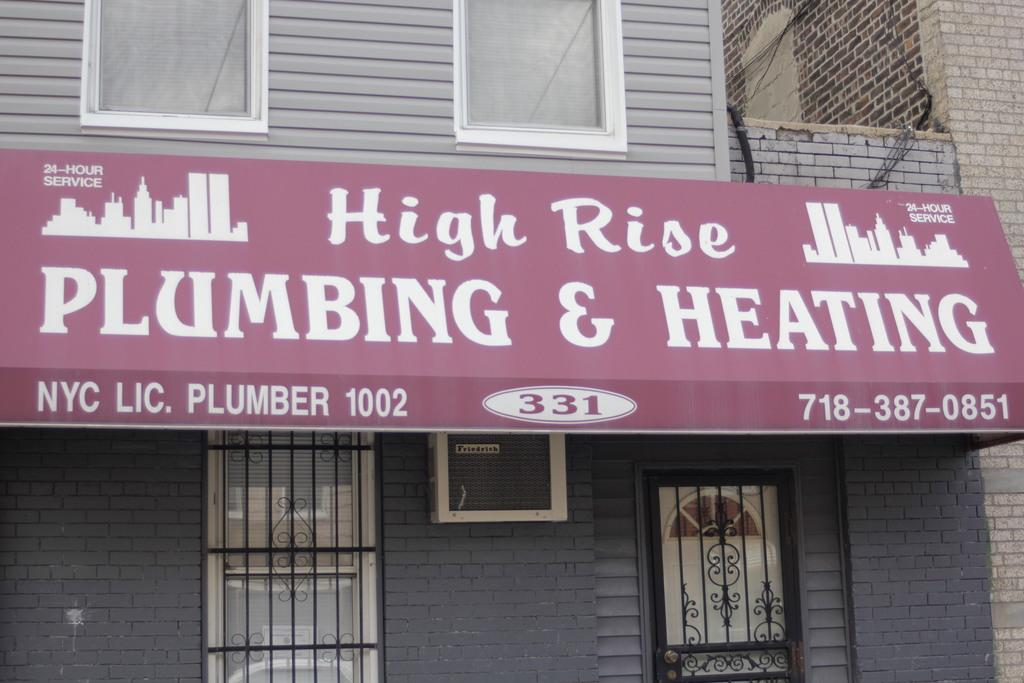What is the main structure in the image? There is a building in the image. What feature can be seen on the building? The building has windows. Is there any text visible in the image? Yes, there is a board with text on the building. How many deer can be seen grazing near the building in the image? There are no deer present in the image; it only features a building with windows and a board with text. 